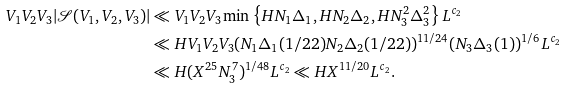Convert formula to latex. <formula><loc_0><loc_0><loc_500><loc_500>V _ { 1 } V _ { 2 } V _ { 3 } | \mathcal { S } ( V _ { 1 } , V _ { 2 } , V _ { 3 } ) | & \ll V _ { 1 } V _ { 2 } V _ { 3 } \min \left \{ H N _ { 1 } \Delta _ { 1 } , H N _ { 2 } \Delta _ { 2 } , H N _ { 3 } ^ { 2 } \Delta _ { 3 } ^ { 2 } \right \} L ^ { c _ { 2 } } \\ & \ll H V _ { 1 } V _ { 2 } V _ { 3 } ( N _ { 1 } \Delta _ { 1 } ( 1 / 2 2 ) N _ { 2 } \Delta _ { 2 } ( 1 / 2 2 ) ) ^ { 1 1 / 2 4 } ( N _ { 3 } \Delta _ { 3 } ( 1 ) ) ^ { 1 / 6 } L ^ { c _ { 2 } } \\ & \ll H ( X ^ { 2 5 } N _ { 3 } ^ { 7 } ) ^ { 1 / 4 8 } L ^ { c _ { 2 } } \ll H X ^ { 1 1 / 2 0 } L ^ { c _ { 2 } } .</formula> 